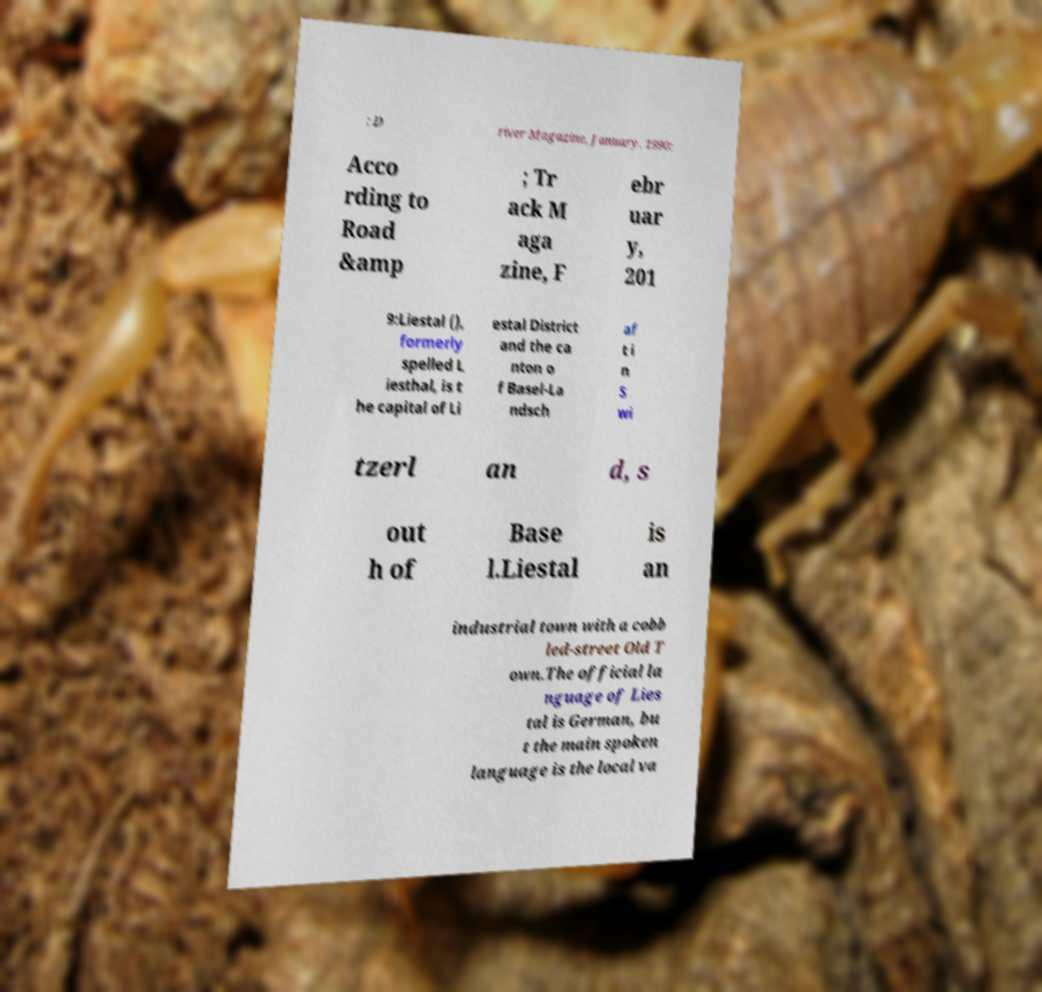Could you assist in decoding the text presented in this image and type it out clearly? ; D river Magazine, January, 1990: Acco rding to Road &amp ; Tr ack M aga zine, F ebr uar y, 201 9:Liestal (), formerly spelled L iesthal, is t he capital of Li estal District and the ca nton o f Basel-La ndsch af t i n S wi tzerl an d, s out h of Base l.Liestal is an industrial town with a cobb led-street Old T own.The official la nguage of Lies tal is German, bu t the main spoken language is the local va 